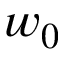Convert formula to latex. <formula><loc_0><loc_0><loc_500><loc_500>w _ { 0 }</formula> 